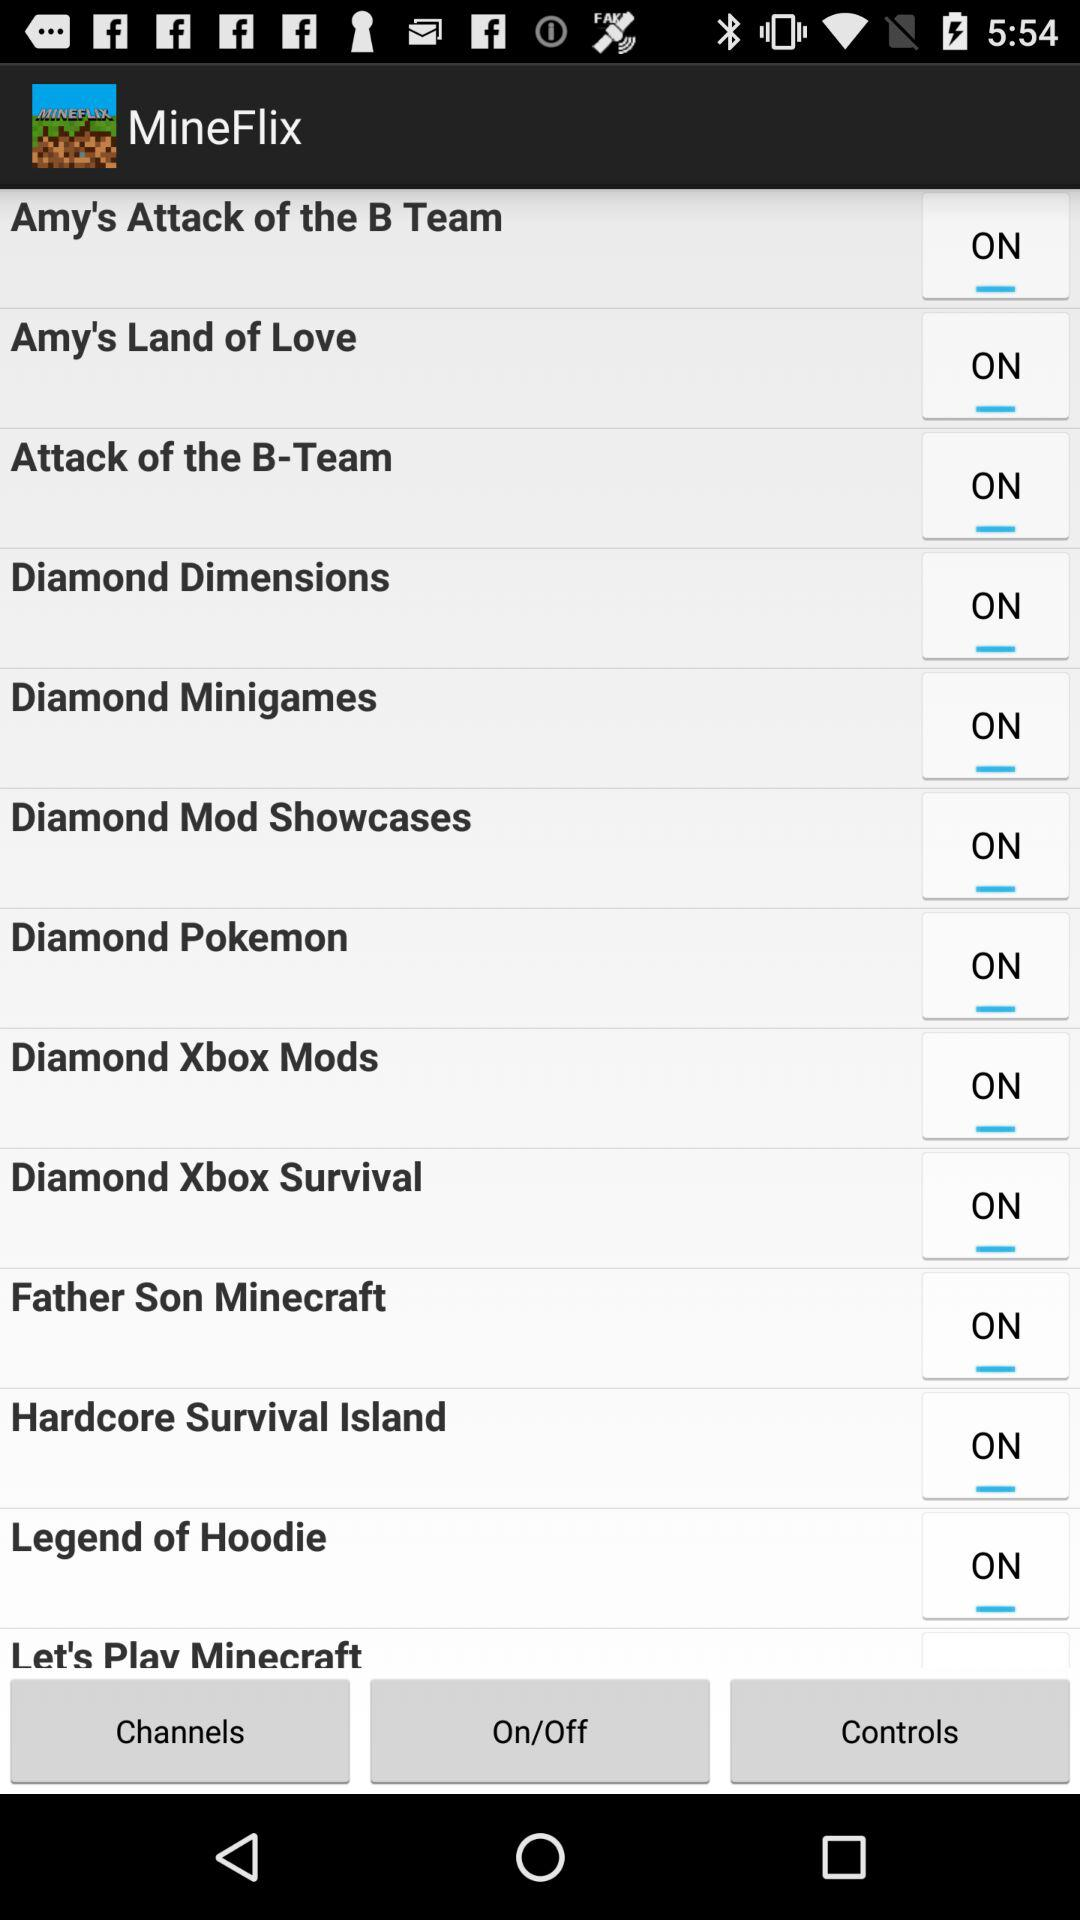What is the current status of the "Diamond Pokemon"? The current status of the "Diamond Pokemon" is "on". 